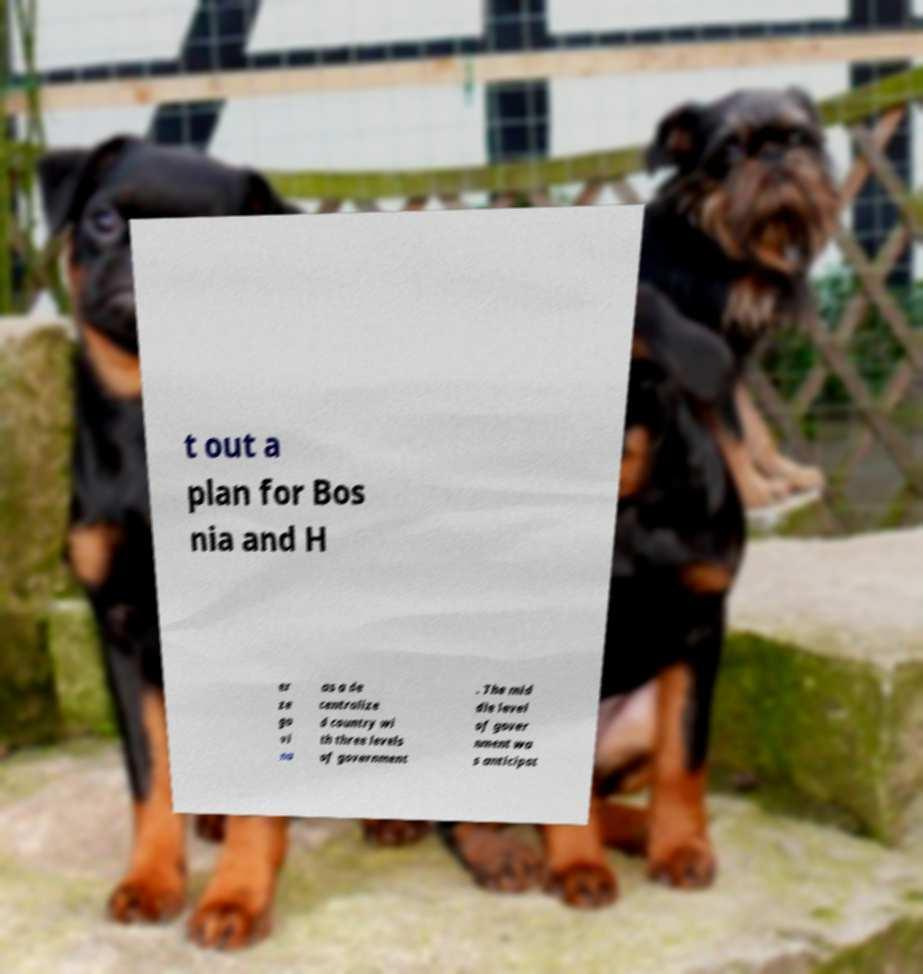Can you read and provide the text displayed in the image?This photo seems to have some interesting text. Can you extract and type it out for me? t out a plan for Bos nia and H er ze go vi na as a de centralize d country wi th three levels of government . The mid dle level of gover nment wa s anticipat 